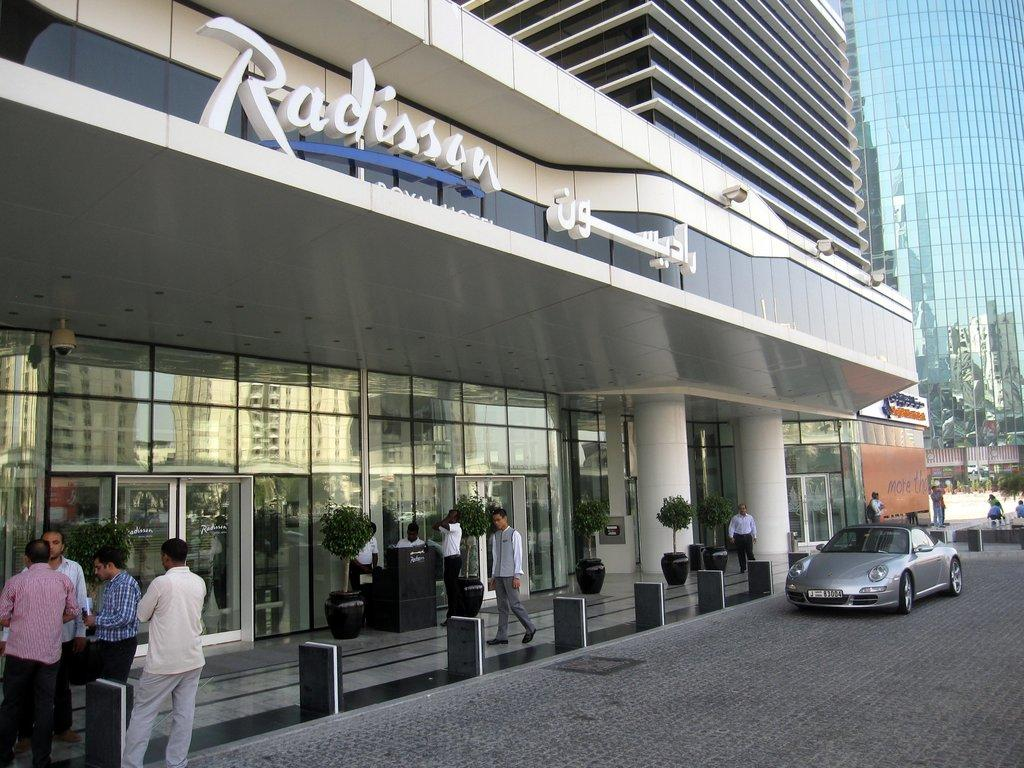What type of structures can be seen in the image? There are buildings in the image. What else is present in the image besides buildings? There are plants, a group of people, a car on the right side, lights, and hoardings in the image. What type of crayon is being used to draw on the hoardings in the image? There is no crayon present in the image, and no one is drawing on the hoardings. 